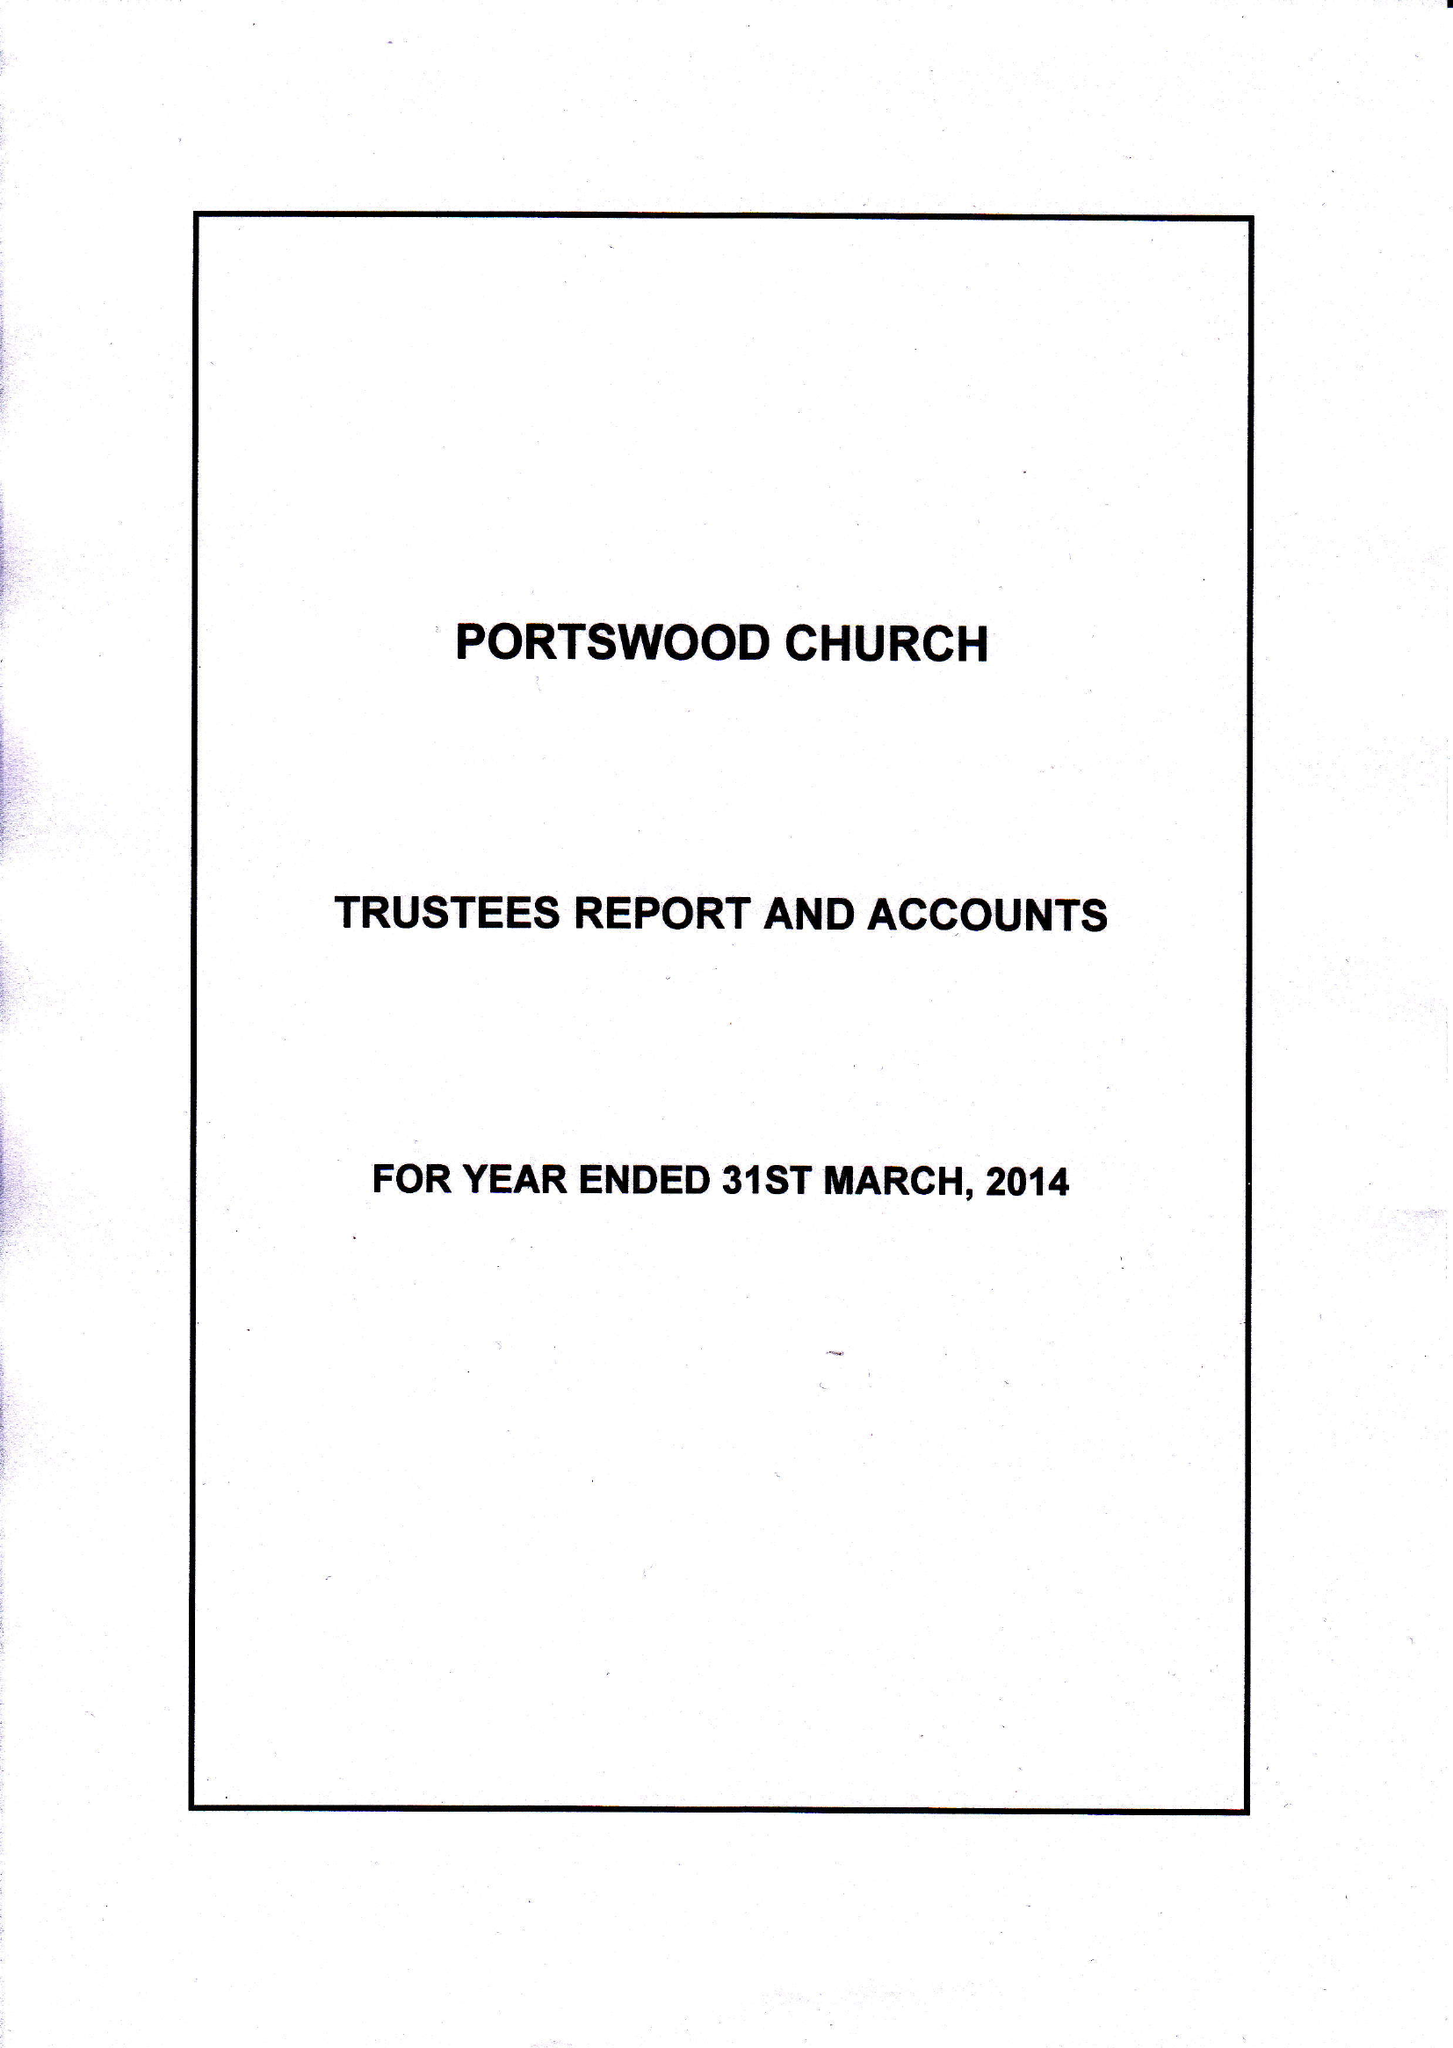What is the value for the address__postcode?
Answer the question using a single word or phrase. SO17 2FY 